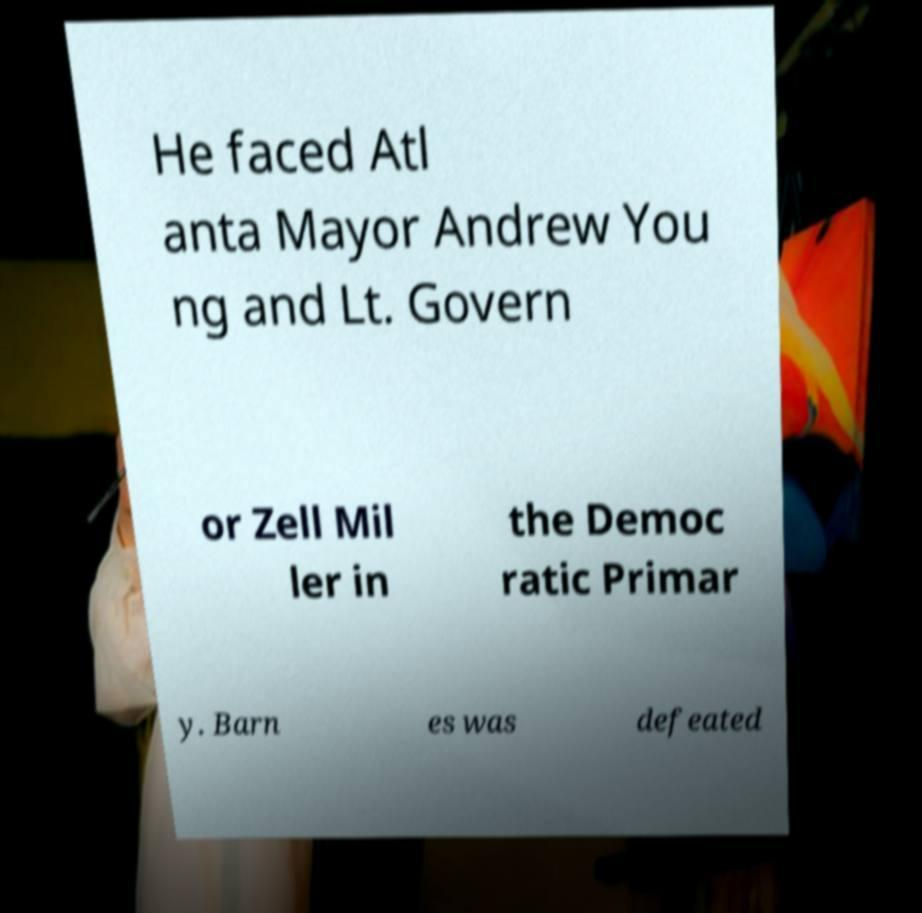There's text embedded in this image that I need extracted. Can you transcribe it verbatim? He faced Atl anta Mayor Andrew You ng and Lt. Govern or Zell Mil ler in the Democ ratic Primar y. Barn es was defeated 